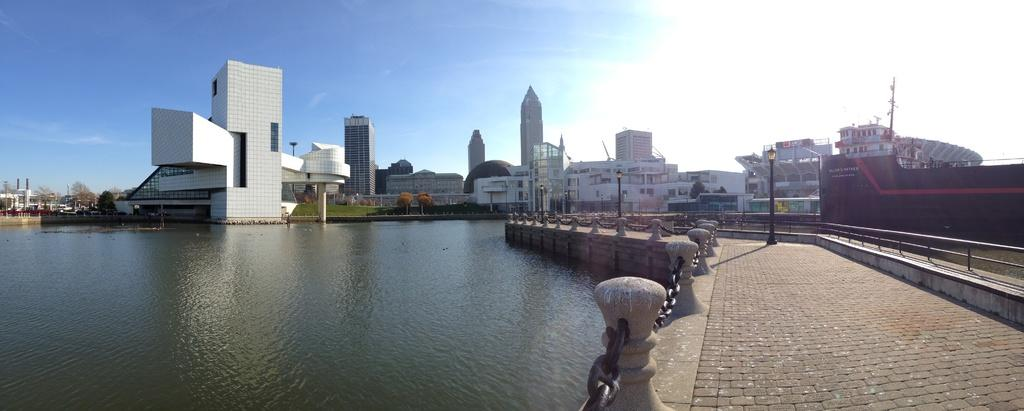What type of structures can be seen in the image? There are buildings in the image. What natural elements are present in the image? There are trees in the image. What part of the environment is visible in the image? The ground is visible in the image. What type of urban infrastructure is present in the image? There are poles (street poles) and street lights in the image. What type of path is available for walking or jogging? There is a walking path in the image. What type of barrier is present in the image? There is a concrete grill in the image. What type of restraint is present in the image? There is a chain in the image. What type of water body is present in the image? There is a lake in the image. What part of the sky is visible in the image? The sky is visible in the image. What type of atmospheric feature is present in the sky? There are clouds in the sky. How do the pets in the image express their regret for not helping with the chores? There are no pets present in the image, and therefore no such expression of regret can be observed. 